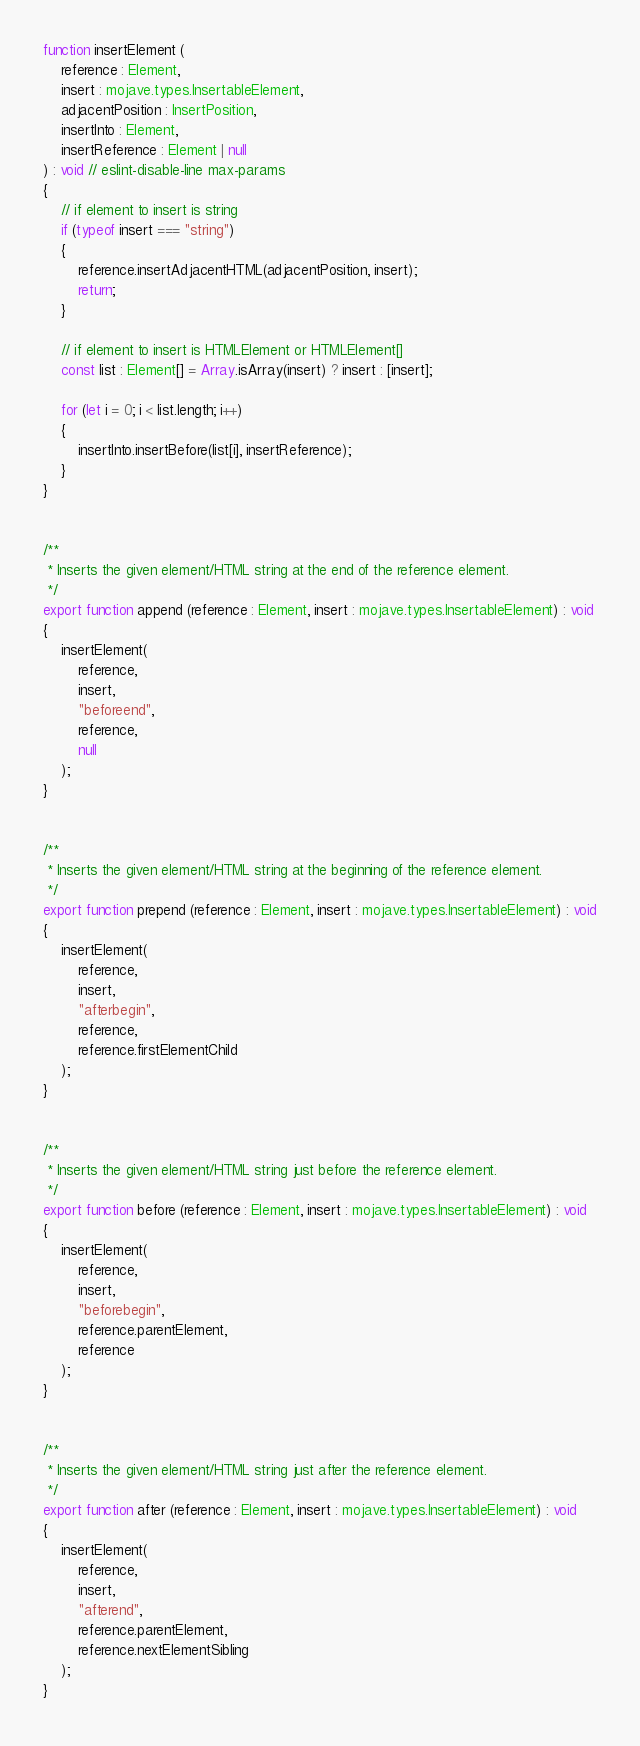<code> <loc_0><loc_0><loc_500><loc_500><_TypeScript_>function insertElement (
    reference : Element,
    insert : mojave.types.InsertableElement,
    adjacentPosition : InsertPosition,
    insertInto : Element,
    insertReference : Element | null
) : void // eslint-disable-line max-params
{
    // if element to insert is string
    if (typeof insert === "string")
    {
        reference.insertAdjacentHTML(adjacentPosition, insert);
        return;
    }

    // if element to insert is HTMLElement or HTMLElement[]
    const list : Element[] = Array.isArray(insert) ? insert : [insert];

    for (let i = 0; i < list.length; i++)
    {
        insertInto.insertBefore(list[i], insertReference);
    }
}


/**
 * Inserts the given element/HTML string at the end of the reference element.
 */
export function append (reference : Element, insert : mojave.types.InsertableElement) : void
{
    insertElement(
        reference,
        insert,
        "beforeend",
        reference,
        null
    );
}


/**
 * Inserts the given element/HTML string at the beginning of the reference element.
 */
export function prepend (reference : Element, insert : mojave.types.InsertableElement) : void
{
    insertElement(
        reference,
        insert,
        "afterbegin",
        reference,
        reference.firstElementChild
    );
}


/**
 * Inserts the given element/HTML string just before the reference element.
 */
export function before (reference : Element, insert : mojave.types.InsertableElement) : void
{
    insertElement(
        reference,
        insert,
        "beforebegin",
        reference.parentElement,
        reference
    );
}


/**
 * Inserts the given element/HTML string just after the reference element.
 */
export function after (reference : Element, insert : mojave.types.InsertableElement) : void
{
    insertElement(
        reference,
        insert,
        "afterend",
        reference.parentElement,
        reference.nextElementSibling
    );
}
</code> 